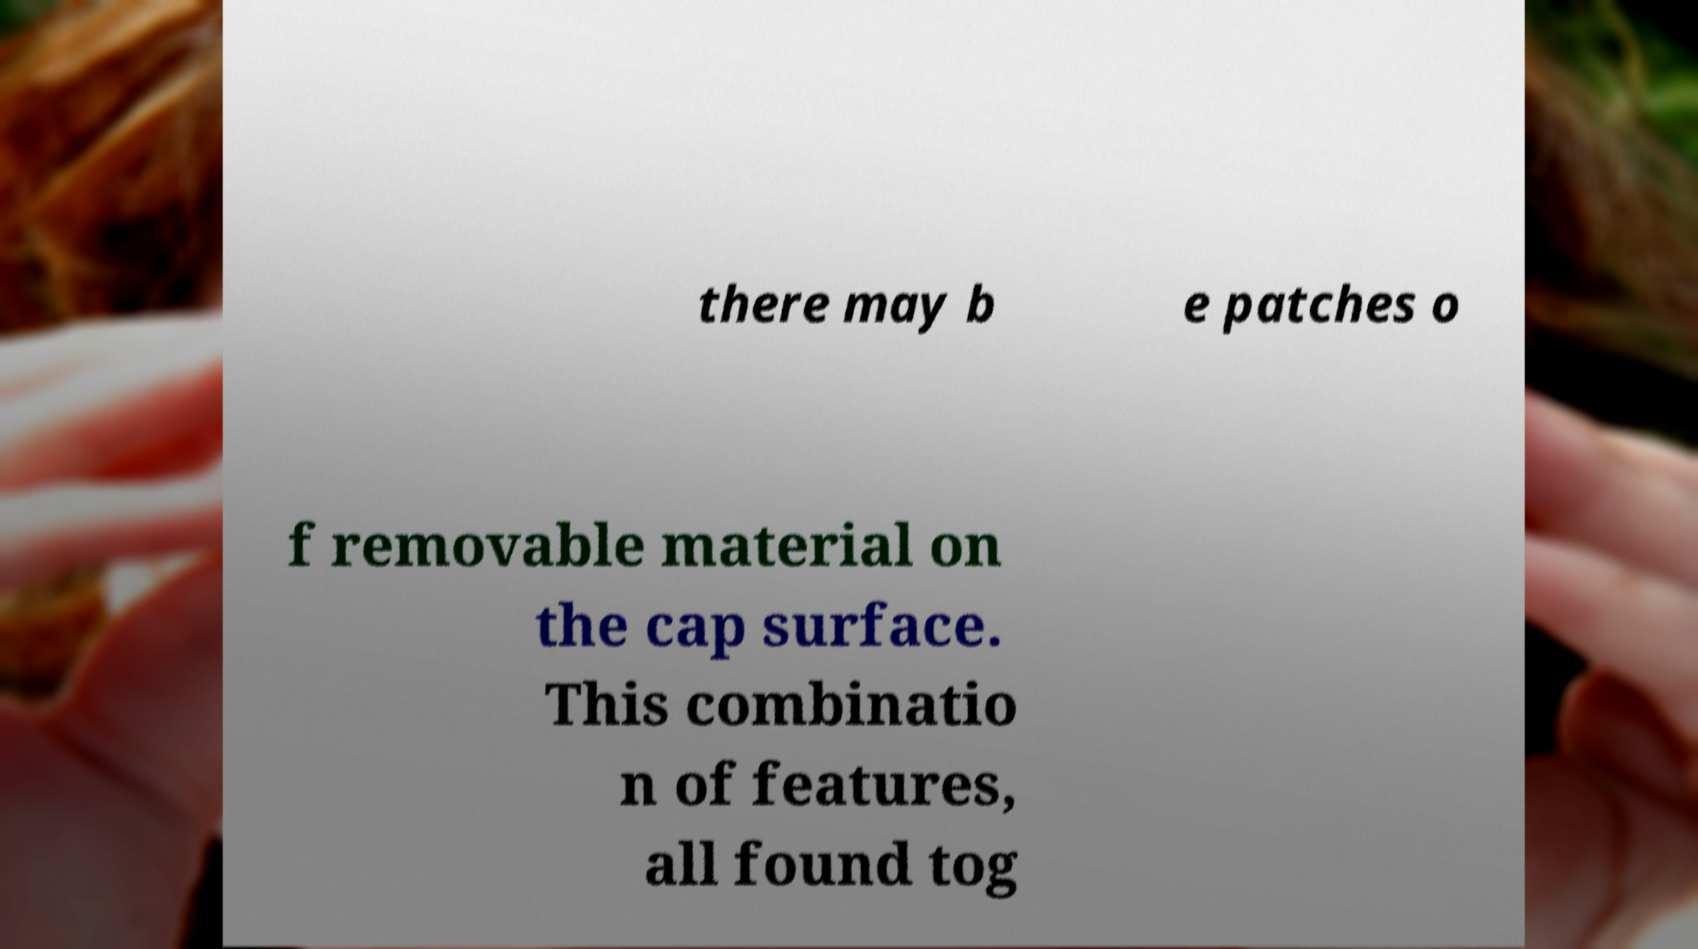Can you accurately transcribe the text from the provided image for me? there may b e patches o f removable material on the cap surface. This combinatio n of features, all found tog 